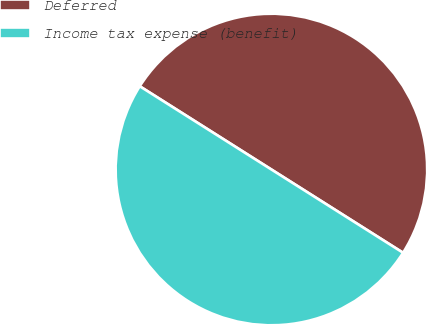Convert chart. <chart><loc_0><loc_0><loc_500><loc_500><pie_chart><fcel>Deferred<fcel>Income tax expense (benefit)<nl><fcel>50.0%<fcel>50.0%<nl></chart> 